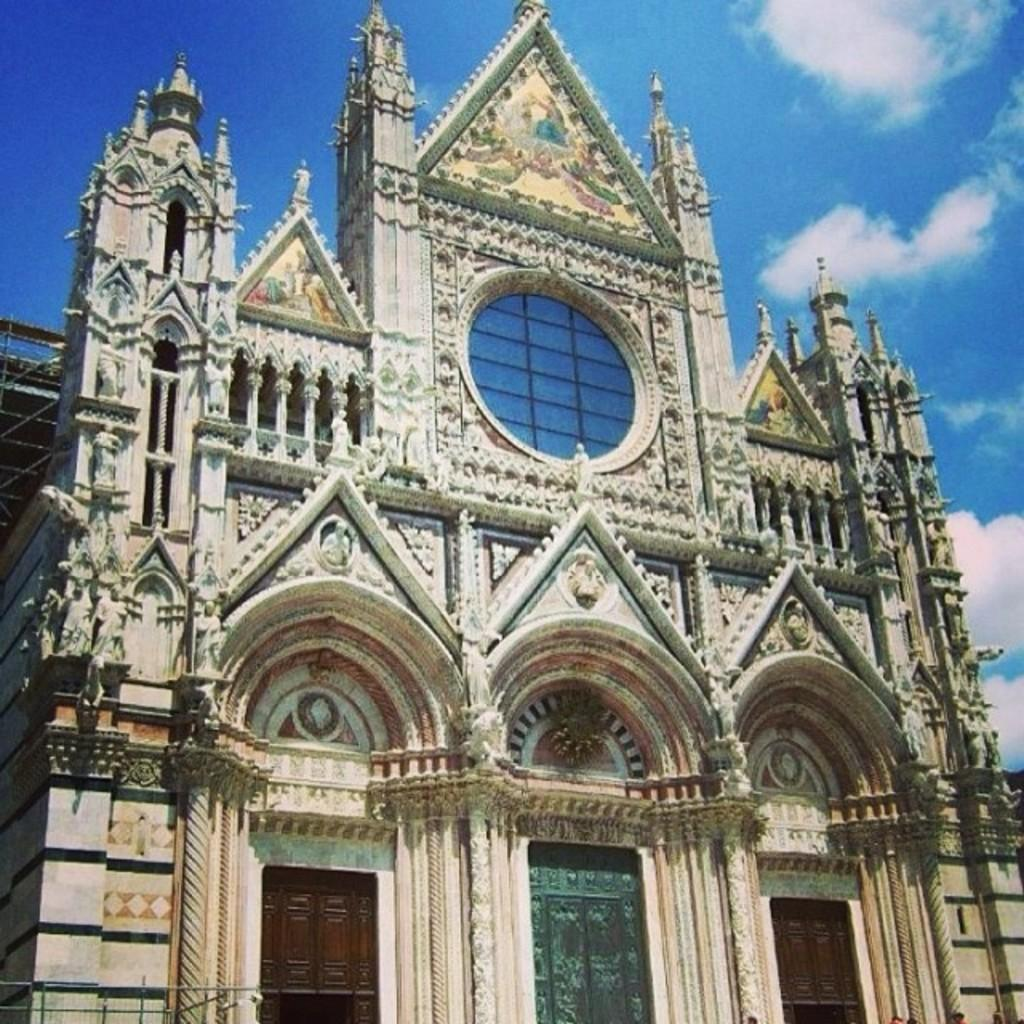What structure is depicted in the image? There is a building in the image. What decorative elements are present on the building? There are statues on the building. What can be seen in the background of the image? There are clouds and a blue sky in the background of the image. Can you see any waves crashing against the building in the image? No, there are no waves present in the image. The image features a building with statues, clouds, and a blue sky in the background. 